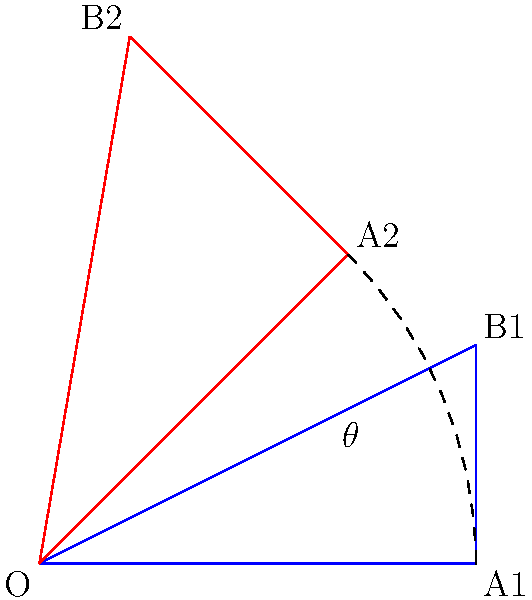In a 2D game, a sprite is rotated from its initial position (blue triangle) to a new position (red triangle). Given that the coordinates of point A change from (2,0) to (1.414,1.414), what is the rotation angle $\theta$ in degrees? To solve this problem, we'll follow these steps:

1) We can use the arctangent function to find the angle. The formula is:
   $\theta = \arctan(\frac{y}{x})$

2) For the initial position (A1), we have:
   $x_1 = 2, y_1 = 0$

3) For the final position (A2), we have:
   $x_2 = 1.414, y_2 = 1.414$

4) The rotation angle is the difference between the angles of these two positions:
   $\theta = \arctan(\frac{y_2}{x_2}) - \arctan(\frac{y_1}{x_1})$

5) Substituting the values:
   $\theta = \arctan(\frac{1.414}{1.414}) - \arctan(\frac{0}{2})$

6) Simplify:
   $\theta = \arctan(1) - 0$

7) $\arctan(1) = 45°$

8) Therefore, $\theta = 45° - 0° = 45°$
Answer: 45° 